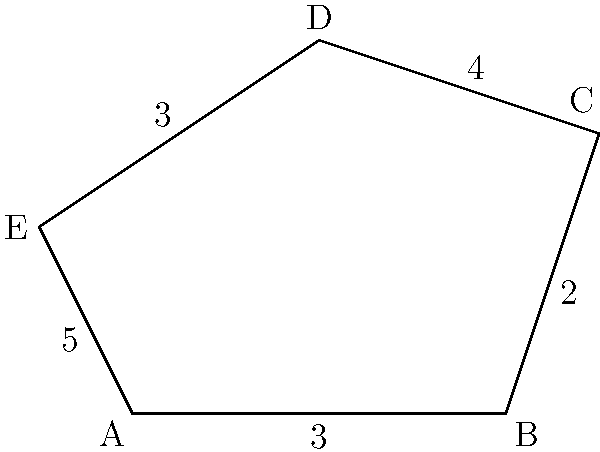Given the irregular pentagon ABCDE with side lengths as shown in the figure, calculate its perimeter. To calculate the perimeter of the irregular pentagon, we need to sum up the lengths of all its sides. Let's go through this step-by-step:

1. Identify the lengths of each side:
   - Side AB = 3
   - Side BC = 2
   - Side CD = 4
   - Side DE = 3
   - Side EA = 5

2. Add up all the side lengths:
   $$\text{Perimeter} = AB + BC + CD + DE + EA$$
   $$\text{Perimeter} = 3 + 2 + 4 + 3 + 5$$

3. Perform the addition:
   $$\text{Perimeter} = 17$$

Therefore, the perimeter of the irregular pentagon is 17 units.
Answer: 17 units 